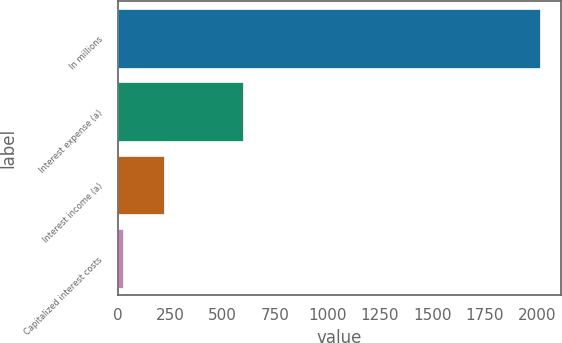Convert chart. <chart><loc_0><loc_0><loc_500><loc_500><bar_chart><fcel>In millions<fcel>Interest expense (a)<fcel>Interest income (a)<fcel>Capitalized interest costs<nl><fcel>2011<fcel>596<fcel>220.9<fcel>22<nl></chart> 